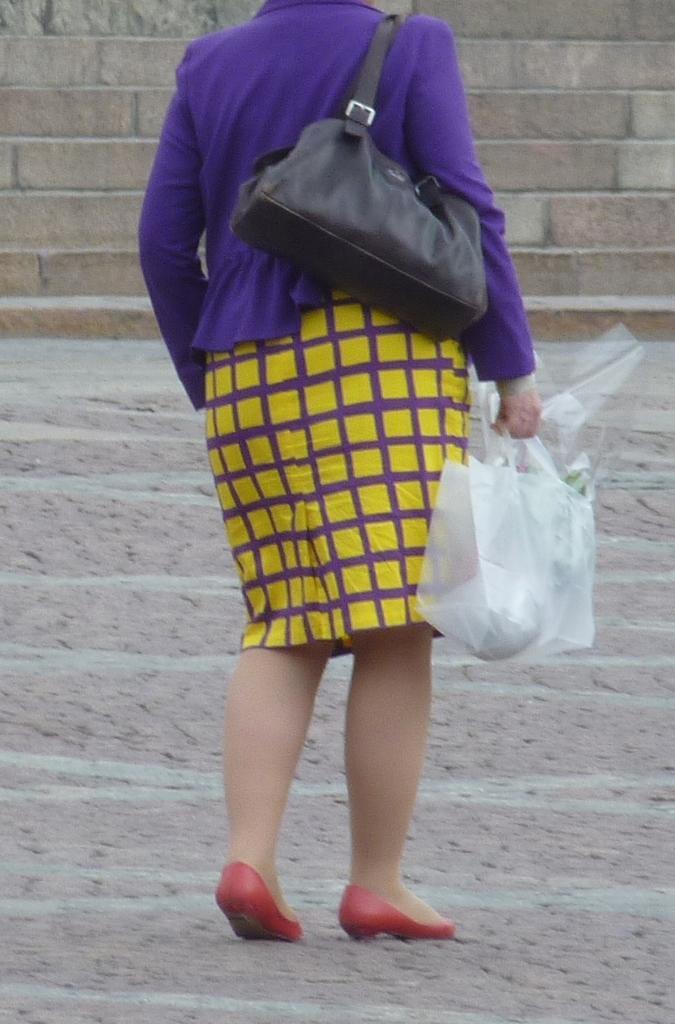Describe this image in one or two sentences. This picture is of outside. In the center there is a woman wearing a sling bag, holding ab bag in her hand and seems to be walking on the ground. In the background we can see a brick wall. 